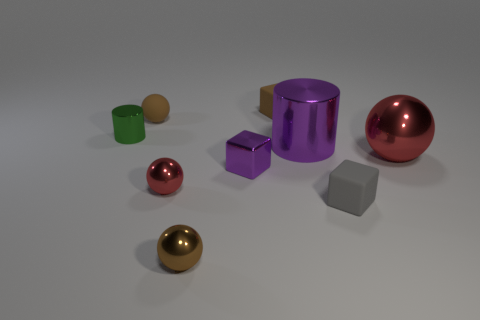Do the green object and the cylinder on the right side of the tiny metallic cylinder have the same size?
Make the answer very short. No. How many brown balls are there?
Make the answer very short. 2. What number of red things are either shiny objects or metallic blocks?
Your answer should be compact. 2. Are the purple thing that is on the right side of the brown matte cube and the small purple thing made of the same material?
Provide a succinct answer. Yes. How many other objects are the same material as the green object?
Ensure brevity in your answer.  5. What is the material of the small brown cube?
Provide a succinct answer. Rubber. What size is the red thing in front of the purple block?
Give a very brief answer. Small. What number of small red things are right of the red thing to the left of the big shiny cylinder?
Your response must be concise. 0. There is a small gray object that is left of the large red shiny thing; is it the same shape as the purple object that is in front of the large purple cylinder?
Provide a succinct answer. Yes. What number of small objects are in front of the brown block and on the right side of the small green cylinder?
Offer a very short reply. 5. 